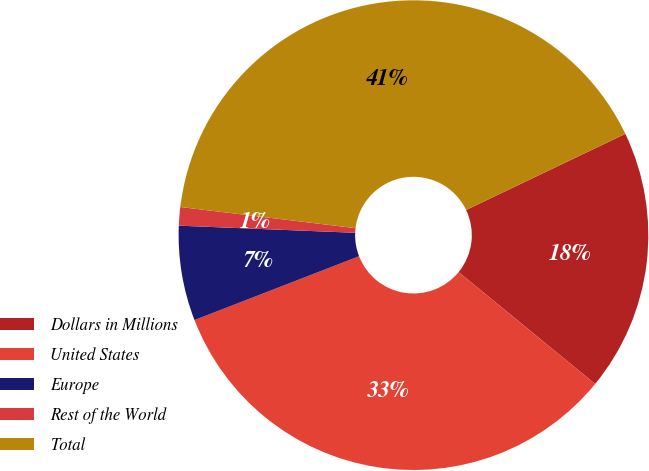Convert chart. <chart><loc_0><loc_0><loc_500><loc_500><pie_chart><fcel>Dollars in Millions<fcel>United States<fcel>Europe<fcel>Rest of the World<fcel>Total<nl><fcel>18.02%<fcel>33.19%<fcel>6.53%<fcel>1.27%<fcel>40.99%<nl></chart> 